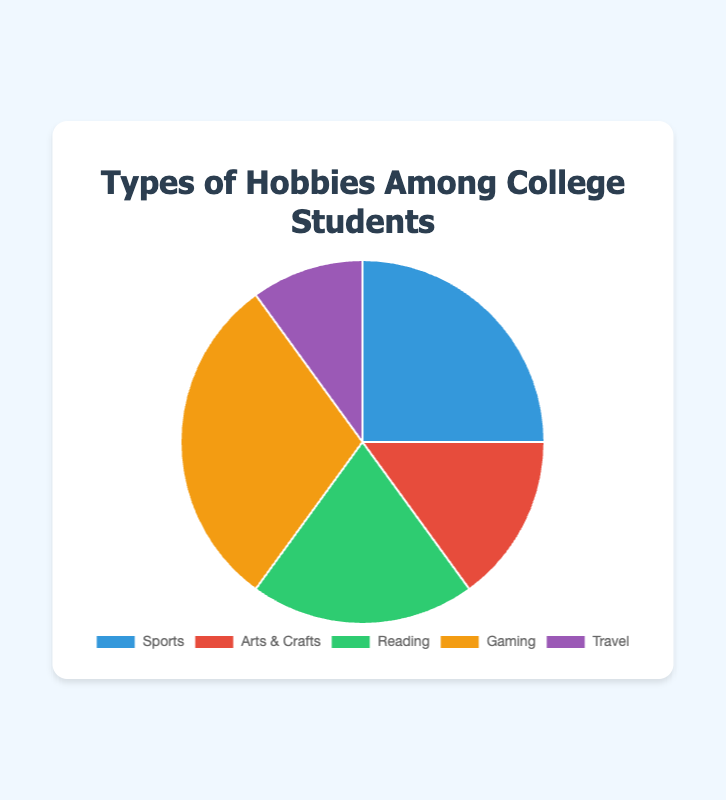Which hobby is the most popular among college students? According to the pie chart, Gaming has the highest percentage at 30%, making it the most popular hobby among college students.
Answer: Gaming What is the total percentage of students who prefer either Reading or Arts & Crafts? From the pie chart, Reading is 20% and Arts & Crafts is 15%. Adding these percentages together, 20% + 15% = 35%.
Answer: 35% How does the popularity of Sports compare to Travel? Sports has a percentage of 25% while Travel has a percentage of 10%. Therefore, Sports is more popular than Travel by 15%.
Answer: Sports is more popular by 15% What is the percentage difference between the most and least popular hobbies? The most popular hobby is Gaming at 30% and the least popular hobby is Travel at 10%. The difference is 30% - 10% = 20%.
Answer: 20% Which hobbies combined make up more than 50% of the total preferences? Adding up the percentages of Gaming (30%) and Sports (25%) gives 55%. This combination makes up more than 50% of the total preferences.
Answer: Gaming and Sports What proportion of the circle is taken up by non-sports hobbies? Adding the percentages of Arts & Crafts (15%), Reading (20%), Gaming (30%), and Travel (10%) results in a total of 75%.
Answer: 75% Rank the hobbies by popularity from highest to lowest. According to the pie chart, the ranking by percentages is: 1) Gaming 30%, 2) Sports 25%, 3) Reading 20%, 4) Arts & Crafts 15%, 5) Travel 10%.
Answer: Gaming, Sports, Reading, Arts & Crafts, Travel Which section of the chart is represented by a green color, and what is its percentage? The green section in the pie chart represents Reading which is 20%.
Answer: Reading - 20% What is the average percentage of Reading and Travel combined? The percentage for Reading is 20% and for Travel is 10%. The average is (20% + 10%) / 2 = 15%.
Answer: 15% If the percentage for Travel doubled, which hobby would it surpass in popularity? If the percentage for Travel doubled from 10% to 20%, it would be equal to Reading's 20%, surpassing Arts & Crafts at 15%.
Answer: Arts & Crafts 